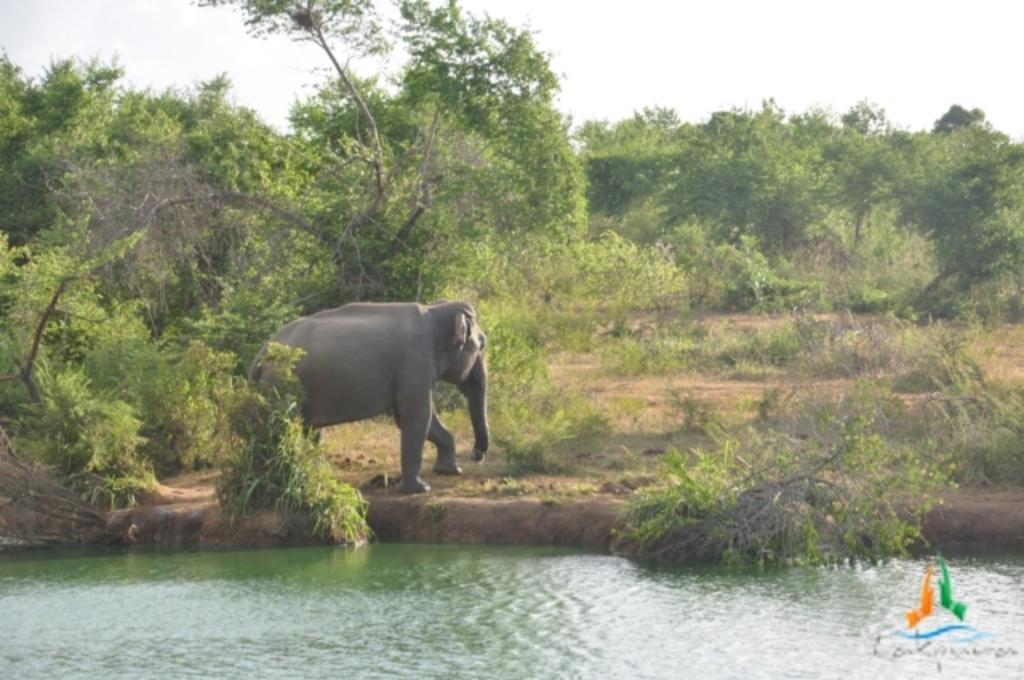Please provide a concise description of this image. In this picture I can see water, plants, there is an elephant standing, there are trees, and in the background there is sky and there is a watermark on the image. 